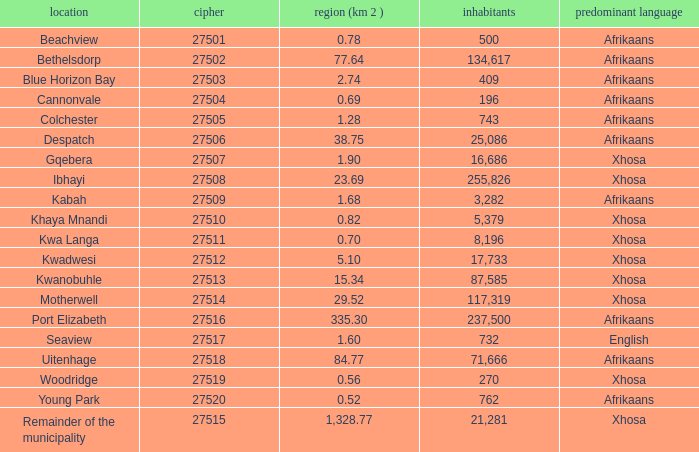What is the total number of area listed for cannonvale with a population less than 409? 1.0. 